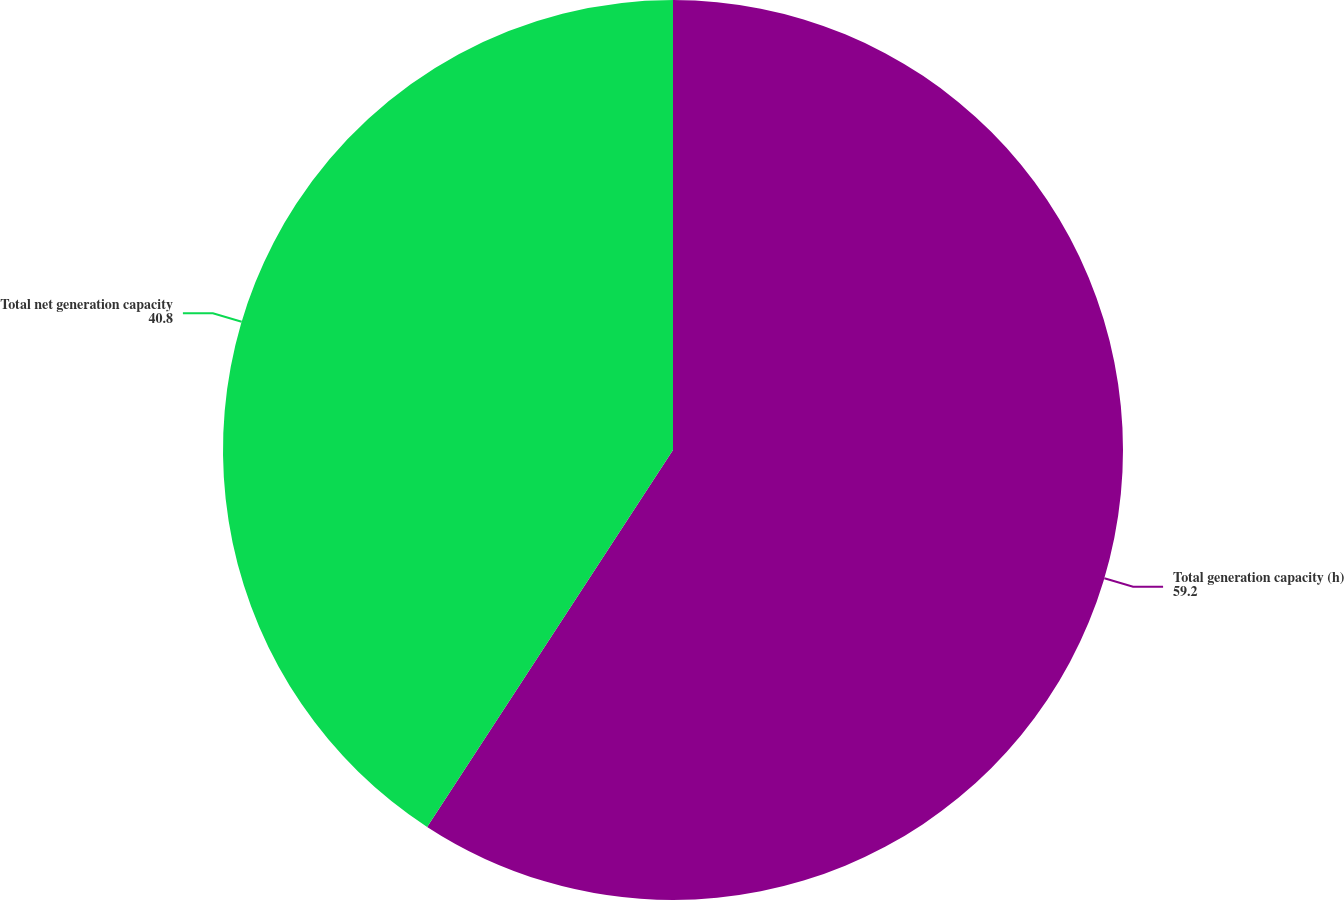Convert chart to OTSL. <chart><loc_0><loc_0><loc_500><loc_500><pie_chart><fcel>Total generation capacity (h)<fcel>Total net generation capacity<nl><fcel>59.2%<fcel>40.8%<nl></chart> 